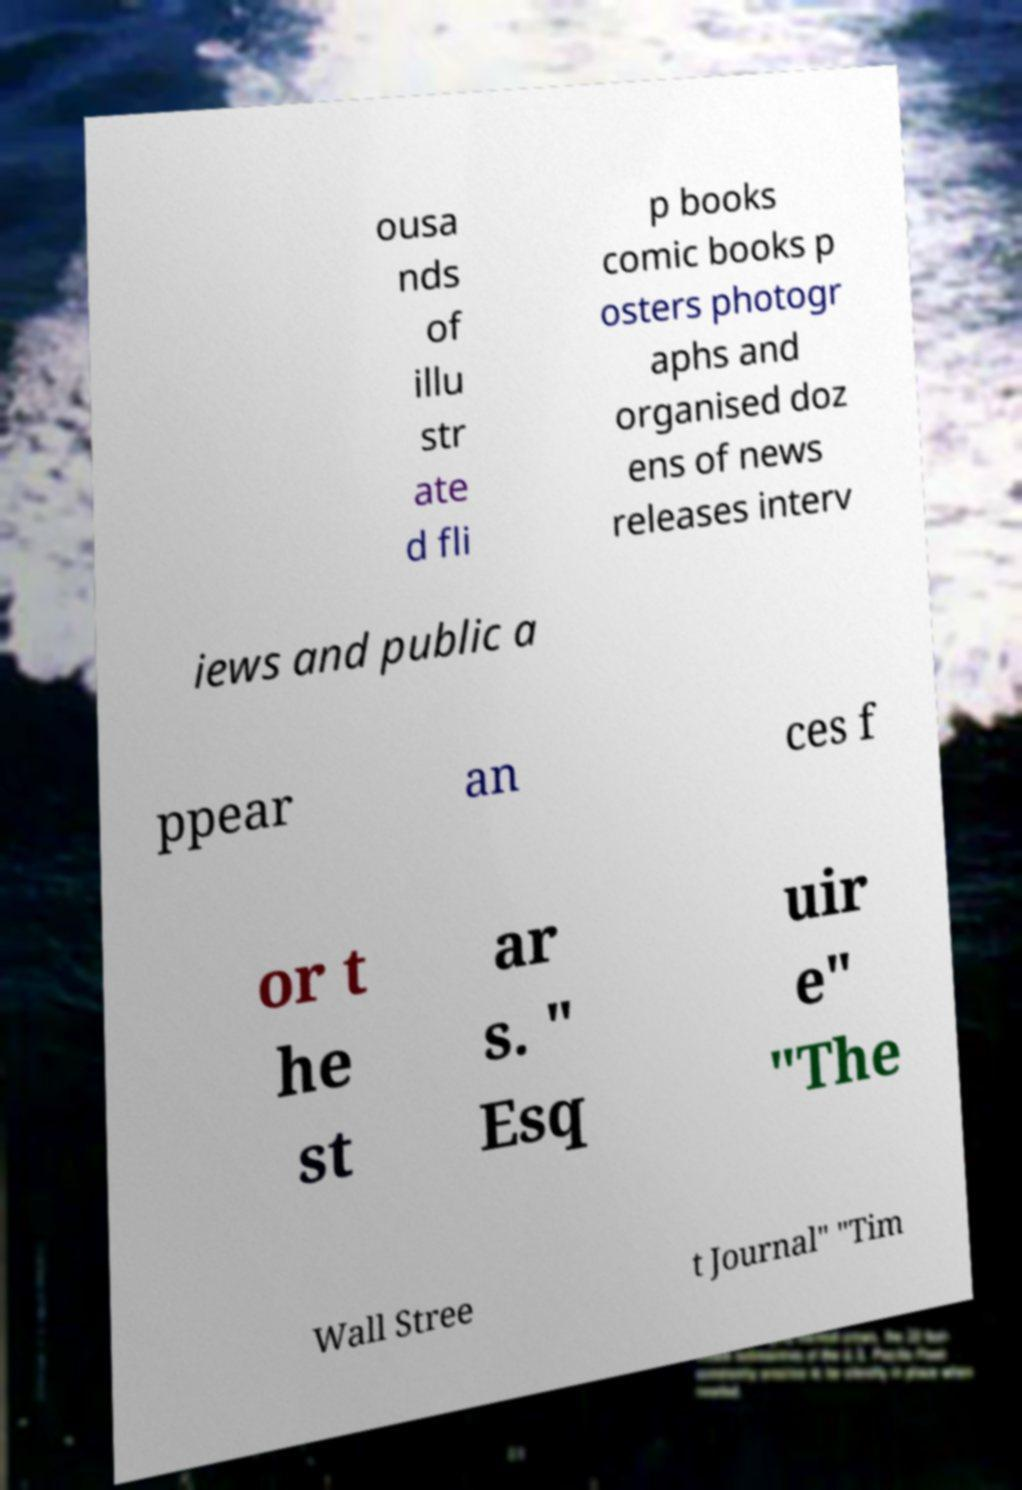What messages or text are displayed in this image? I need them in a readable, typed format. ousa nds of illu str ate d fli p books comic books p osters photogr aphs and organised doz ens of news releases interv iews and public a ppear an ces f or t he st ar s. " Esq uir e" "The Wall Stree t Journal" "Tim 